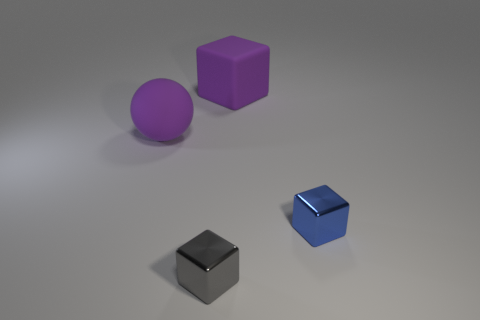Subtract all small metallic cubes. How many cubes are left? 1 Subtract all gray cubes. How many cubes are left? 2 Subtract 2 cubes. How many cubes are left? 1 Subtract all blocks. How many objects are left? 1 Add 1 small gray objects. How many objects exist? 5 Subtract all gray spheres. Subtract all gray cylinders. How many spheres are left? 1 Subtract all red balls. How many green blocks are left? 0 Subtract all big spheres. Subtract all tiny metallic cubes. How many objects are left? 1 Add 3 matte things. How many matte things are left? 5 Add 1 gray blocks. How many gray blocks exist? 2 